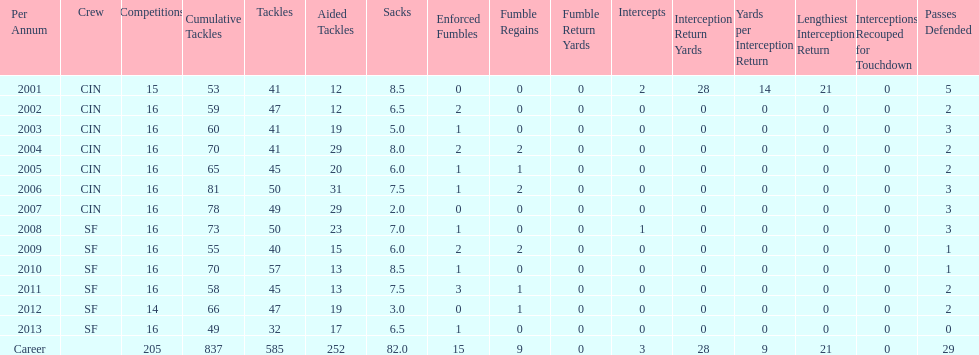What is the total number of sacks smith has made? 82.0. 